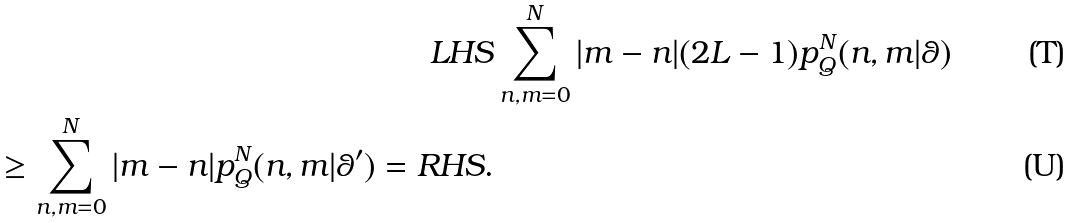Convert formula to latex. <formula><loc_0><loc_0><loc_500><loc_500>L H S & \sum _ { n , m = 0 } ^ { N } | m - n | ( 2 L - 1 ) p _ { Q } ^ { N } ( n , m | \theta ) \\ \geq \sum _ { n , m = 0 } ^ { N } | m - n | p _ { Q } ^ { N } ( n , m | \theta ^ { \prime } ) = R H S .</formula> 